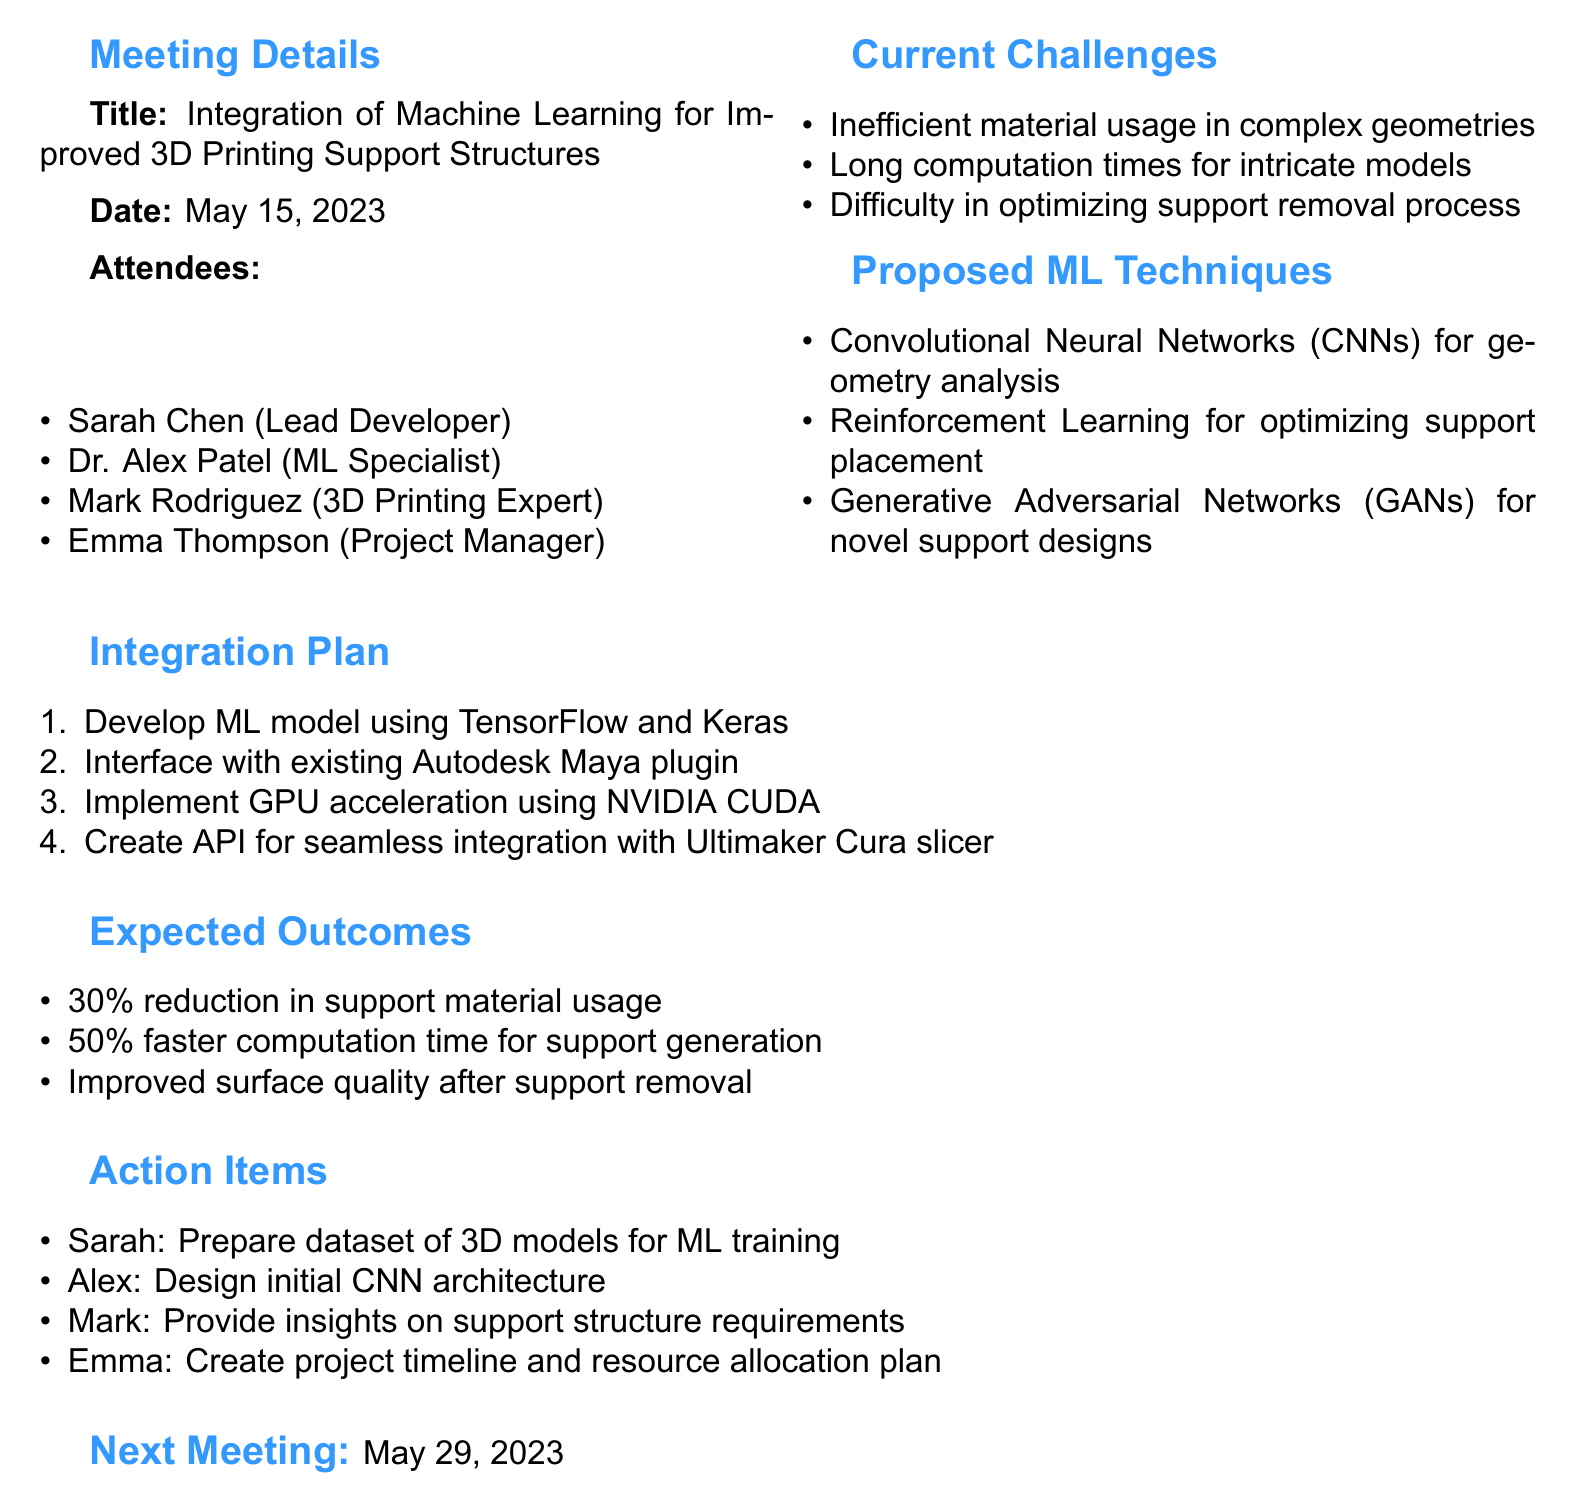What is the meeting title? The meeting title is indicated clearly at the beginning of the document.
Answer: Integration of Machine Learning for Improved 3D Printing Support Structures Who is the lead developer? The lead developer's name is mentioned in the list of attendees within the document.
Answer: Sarah Chen What are the three current challenges listed? The document lists three specific challenges regarding support structure generation.
Answer: Inefficient material usage in complex geometries, long computation times for intricate models, difficulty in optimizing support removal process What ML technique is proposed for optimizing support placement? The proposed ML technique for this purpose is mentioned among the various techniques listed in the document.
Answer: Reinforcement Learning What is the expected reduction in support material usage? This information is provided under the expected outcomes section of the document.
Answer: 30 percent What will Sarah prepare as an action item? The action items section specifies what each attendee is responsible for.
Answer: Prepare dataset of 3D models for ML training On what date is the next meeting scheduled? The document clearly states when the next meeting will occur.
Answer: May 29, 2023 How many attendees are there in total? The attendee list provides the number of participants present at the meeting.
Answer: Four 